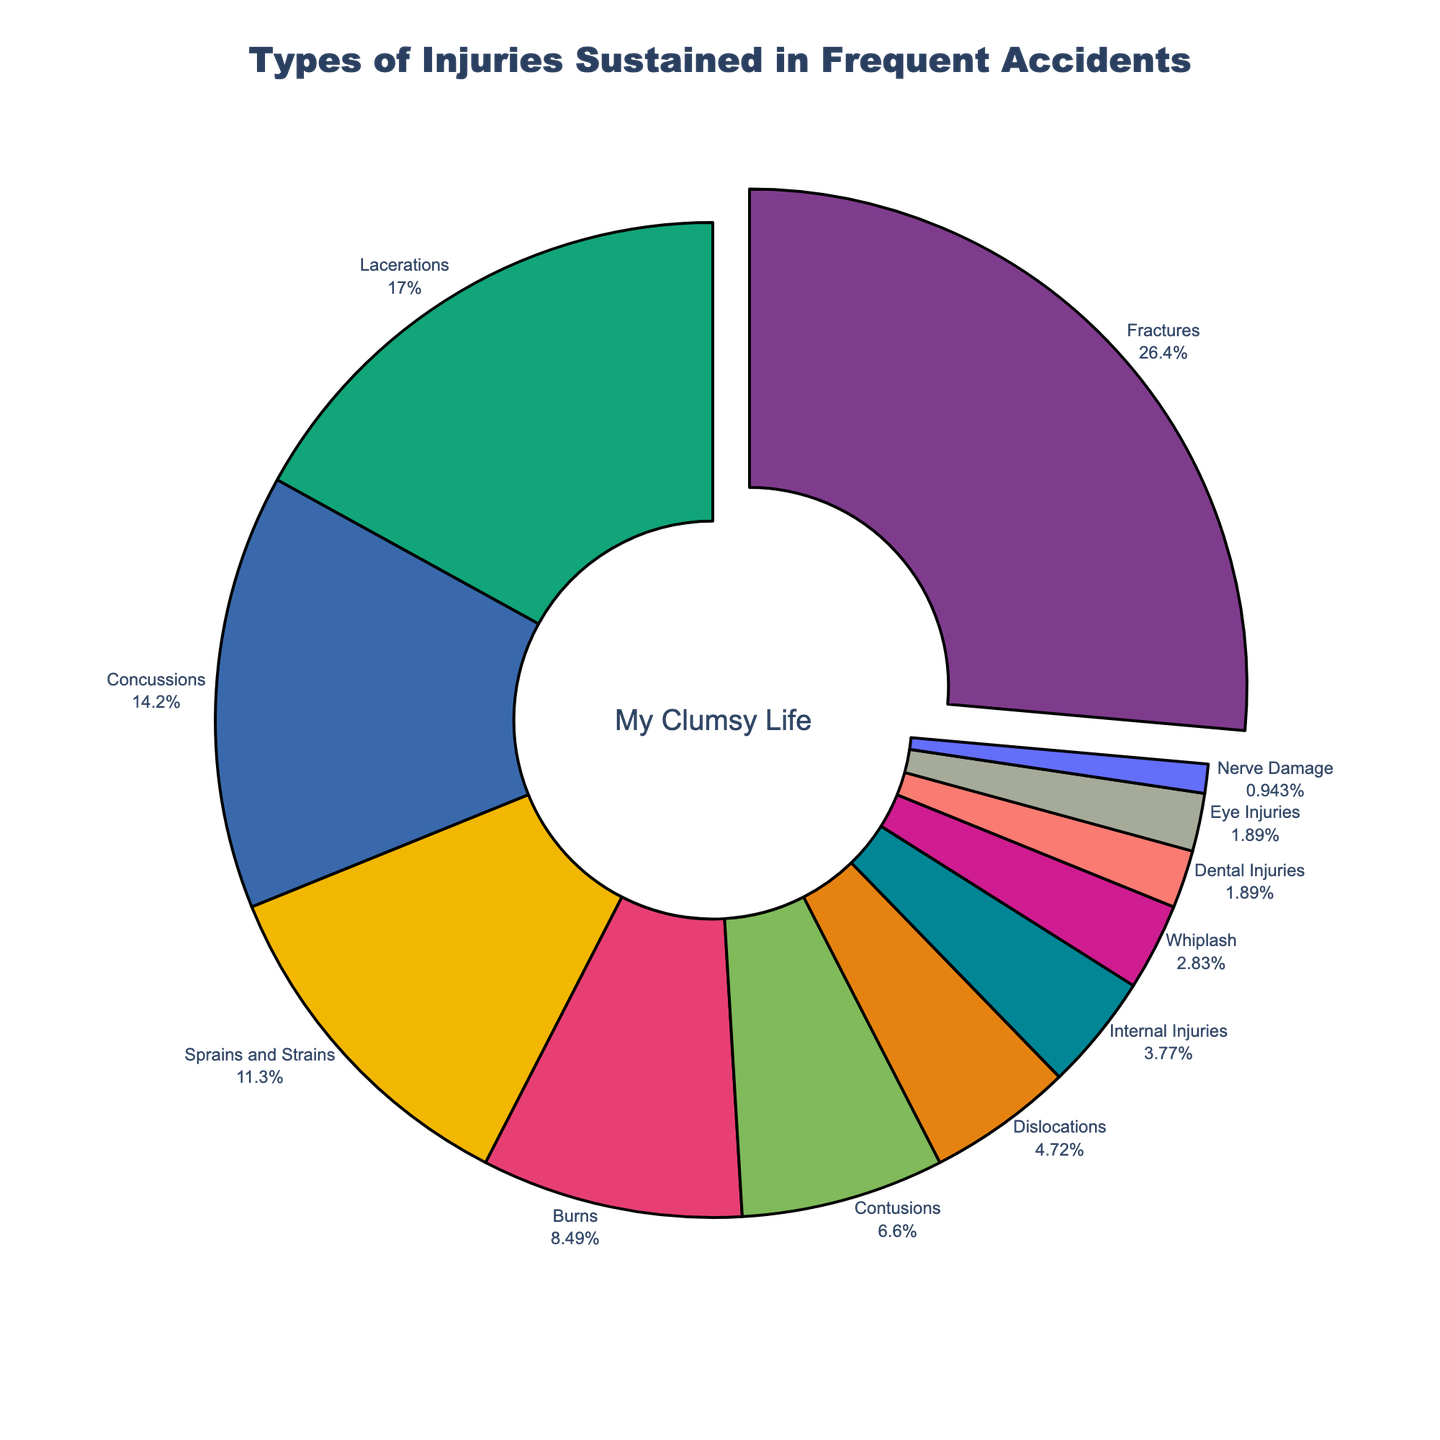What's the most common type of injury? Identify the segment with the highest percentage. It is Fractures at 28%.
Answer: Fractures Which injuries together make up more than 50% of the total? Add up the percentages in descending order until you surpass 50%. Fractures (28%) + Lacerations (18%) = 46%, adding Concussions (15%) reaches 61%.
Answer: Fractures, Lacerations, Concussions Which injury type is the least common? Find the injury type with the smallest percentage value. Nerve Damage is 1%.
Answer: Nerve Damage What's the percentage difference between Fractures and Lacerations? Subtract the percentage of Lacerations (18%) from Fractures (28%). The difference is 28% - 18% = 10%.
Answer: 10% How many injury types compose less than 5% each? Count the injury types with percentages lower than 5%. Dislocations (5%), Internal Injuries (4%), Whiplash (3%), Dental Injuries (2%), Eye Injuries (2%), Nerve Damage (1%). There are 6.
Answer: 6 What is the combined percentage of Sprains and Strains, Burns, and Contusions? Add their percentages: Sprains and Strains (12%) + Burns (9%) + Contusions (7%) = 12% + 9% + 7% = 28%.
Answer: 28% Is the percentage of Contusions greater than Dental Injuries and Eye Injuries combined? Add Dental Injuries (2%) and Eye Injuries (2%) to get 4%. Compare this to Contusions' 7%. 7% is greater than 4%.
Answer: Yes 